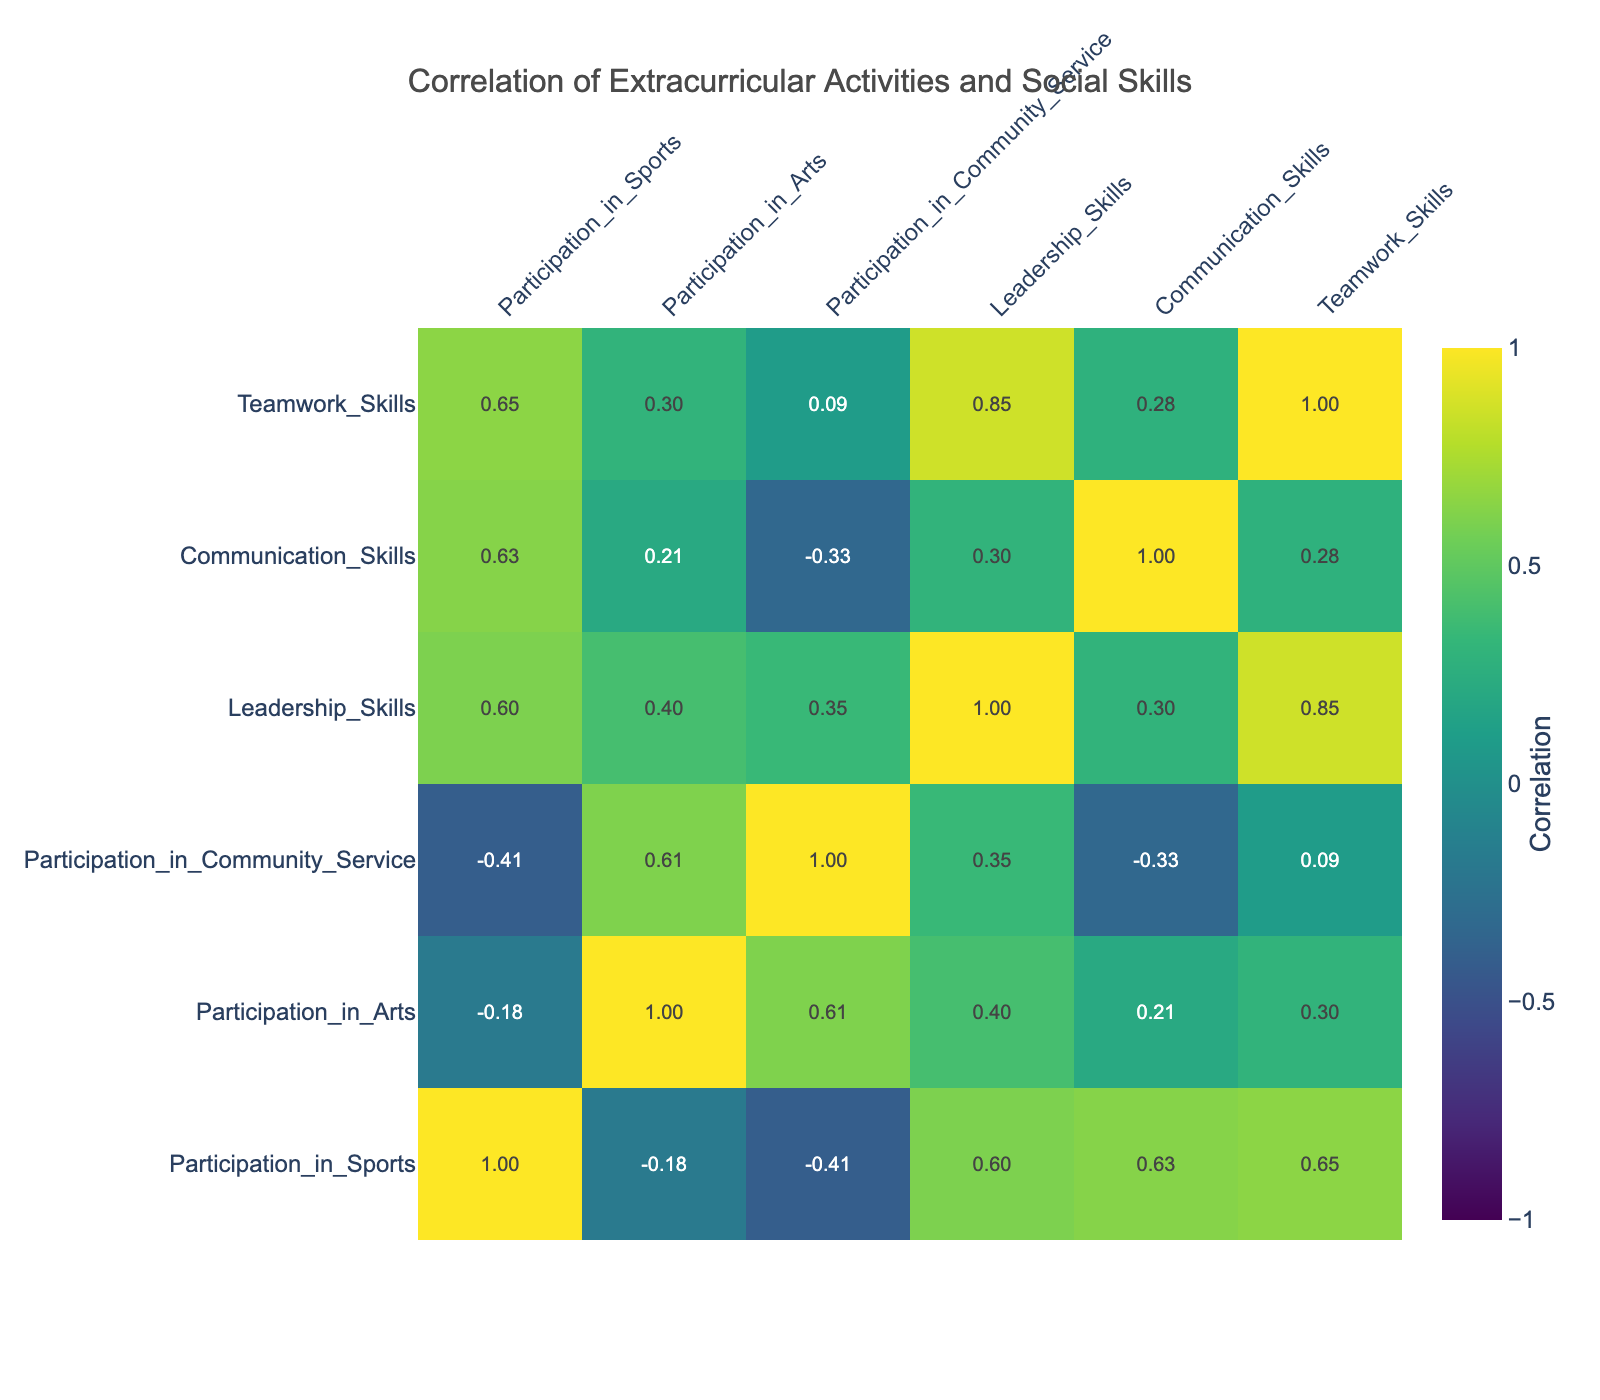What is the correlation between Participation in Sports and Leadership Skills? Looking at the table, we find the correlation value between Participation in Sports and Leadership Skills. By locating the respective row and column in the correlation matrix, it shows a correlation of 0.72, indicating a strong positive relationship.
Answer: 0.72 What is the highest correlation value in the table, and between which two activities does it occur? To find the highest correlation, I will scan the correlation matrix for the maximum value. The highest correlation value is 0.83, occurring between Teamwork Skills and Communication Skills.
Answer: 0.83 between Teamwork Skills and Communication Skills Is there a strong negative correlation between Participation in Arts and Teamwork Skills? By checking the correlation matrix, we can see that the correlation value between Participation in Arts and Teamwork Skills is 0.11, which is not a strong negative correlation but rather a weak positive one.
Answer: No Which two extracurricular activities show the weakest correlation in the table? By analyzing the correlation values, Participation in Arts and Participation in Sports shows the weakest correlation with a value of 0.08. Thus, they are the most independent of each other in this dataset.
Answer: Participation in Arts and Participation in Sports What is the average correlation between Participation in Community Service and social skills (Leadership, Communication, Teamwork)? First, I sum the correlation values for Participation in Community Service: Leadership Skills (0.68), Communication Skills (0.56), and Teamwork Skills (0.62). The total is 0.68 + 0.56 + 0.62 = 1.86, and dividing by 3 gives an average of 0.62.
Answer: 0.62 Is it true that George has the highest scores in both Teamwork Skills and Leadership Skills? By reviewing the data, George scores 10 in Teamwork Skills and 10 in Leadership Skills, thus confirming that he has the highest scores in both categories.
Answer: Yes What is the correlation between Participation in Community Service and Leadership Skills? By locating the values in the table, the correlation between Participation in Community Service and Leadership Skills is found to be 0.68, suggesting a moderately strong relationship.
Answer: 0.68 If we looked at the average scores for communication skills for students who participate in arts vs. those who do not, which group has a higher average? First, identify students who participate in arts (Alice, Bob, Ethan, Fiona, Jasmine) and calculate their Communication Skills' average (8 + 7 + 6 + 8 + 10 = 39, and 39/5 = 7.8). Then, for students not in arts (Charlie, Diana, George, Hannah, Ian), calculate their average (8 + 9 + 9 + 6 + 8 = 40, and 40/5 = 8). Since 8 > 7.8, the students participating in arts have a lower average.
Answer: Students who do not participate in arts have a higher average 